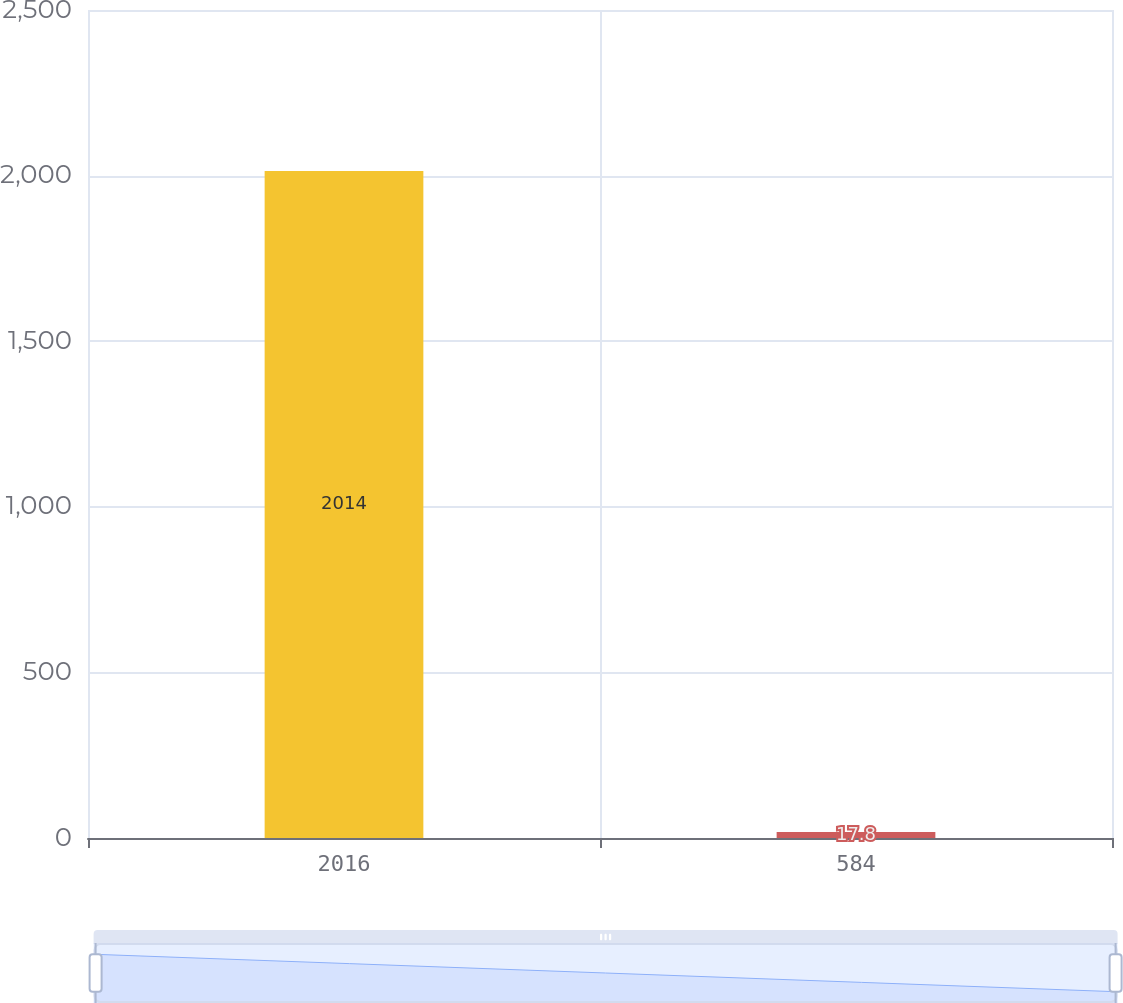<chart> <loc_0><loc_0><loc_500><loc_500><bar_chart><fcel>2016<fcel>584<nl><fcel>2014<fcel>17.8<nl></chart> 